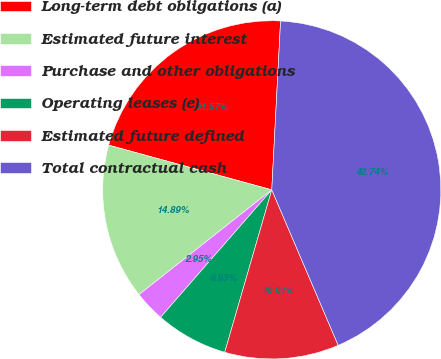Convert chart. <chart><loc_0><loc_0><loc_500><loc_500><pie_chart><fcel>Long-term debt obligations (a)<fcel>Estimated future interest<fcel>Purchase and other obligations<fcel>Operating leases (e)<fcel>Estimated future defined<fcel>Total contractual cash<nl><fcel>21.57%<fcel>14.89%<fcel>2.95%<fcel>6.93%<fcel>10.91%<fcel>42.74%<nl></chart> 